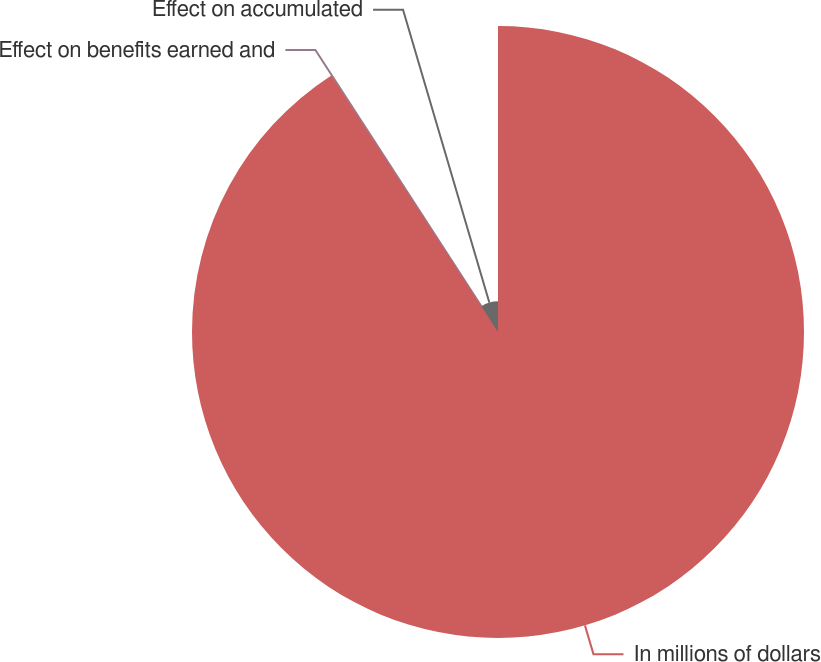<chart> <loc_0><loc_0><loc_500><loc_500><pie_chart><fcel>In millions of dollars<fcel>Effect on benefits earned and<fcel>Effect on accumulated<nl><fcel>90.83%<fcel>0.05%<fcel>9.12%<nl></chart> 